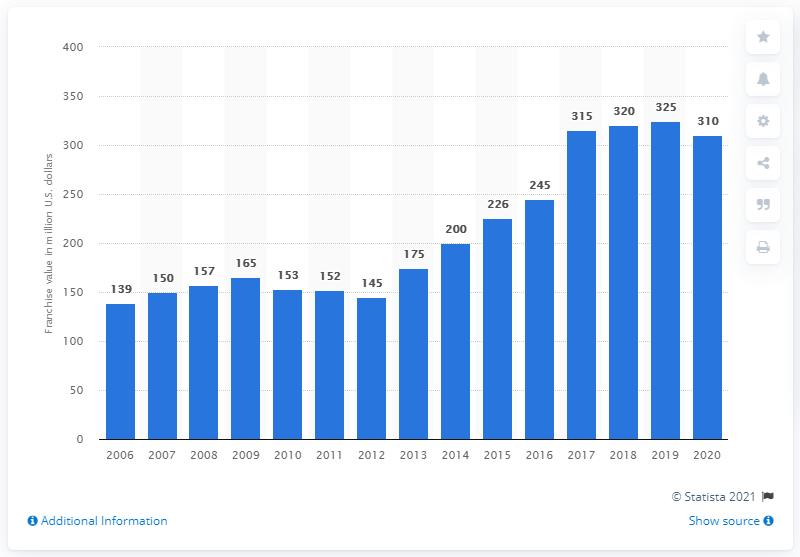Mention a couple of crucial points in this snapshot. The value of the Columbus Blue Jackets franchise in dollars in 2020 was estimated to be approximately 310 million dollars. 